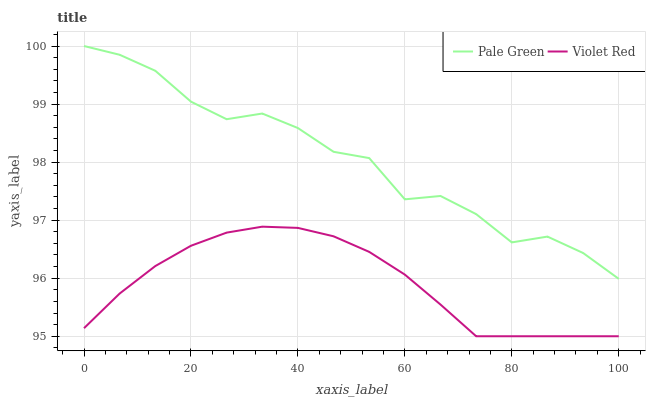Does Violet Red have the minimum area under the curve?
Answer yes or no. Yes. Does Pale Green have the maximum area under the curve?
Answer yes or no. Yes. Does Pale Green have the minimum area under the curve?
Answer yes or no. No. Is Violet Red the smoothest?
Answer yes or no. Yes. Is Pale Green the roughest?
Answer yes or no. Yes. Is Pale Green the smoothest?
Answer yes or no. No. Does Violet Red have the lowest value?
Answer yes or no. Yes. Does Pale Green have the lowest value?
Answer yes or no. No. Does Pale Green have the highest value?
Answer yes or no. Yes. Is Violet Red less than Pale Green?
Answer yes or no. Yes. Is Pale Green greater than Violet Red?
Answer yes or no. Yes. Does Violet Red intersect Pale Green?
Answer yes or no. No. 